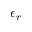Convert formula to latex. <formula><loc_0><loc_0><loc_500><loc_500>\epsilon _ { r }</formula> 